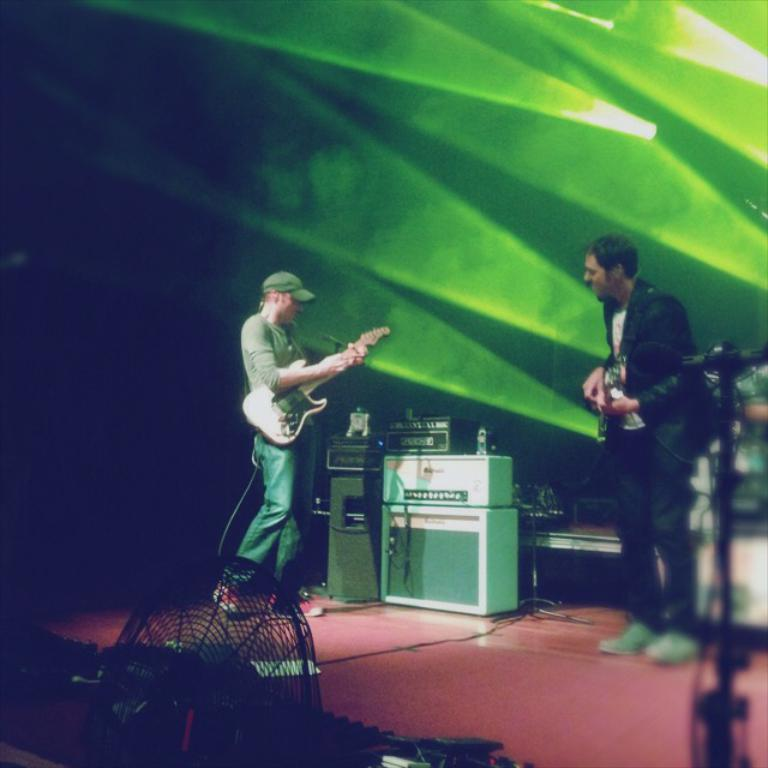What is the person in the image doing? The person is playing a guitar. What is the person wearing? The person is wearing a suit. What objects can be seen in the image besides the person and the guitar? There are devices present and focusing lights on top. What is the purpose of the table fan in the image? The table fan is in front of the stage, possibly to provide ventilation or to cool the person playing the guitar. How many fairies are dancing around the person playing the guitar? There are no fairies present in the image. What type of bead is being used as a guitar pick in the image? There is no bead being used as a guitar pick in the image; the person is using a guitar pick or their fingers to play the guitar. 